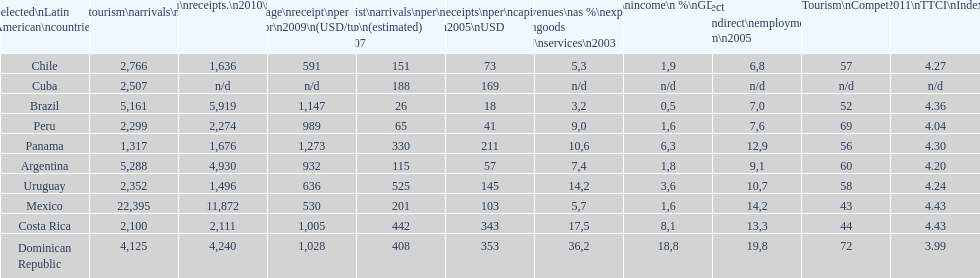What country ranks the best in most categories? Dominican Republic. 